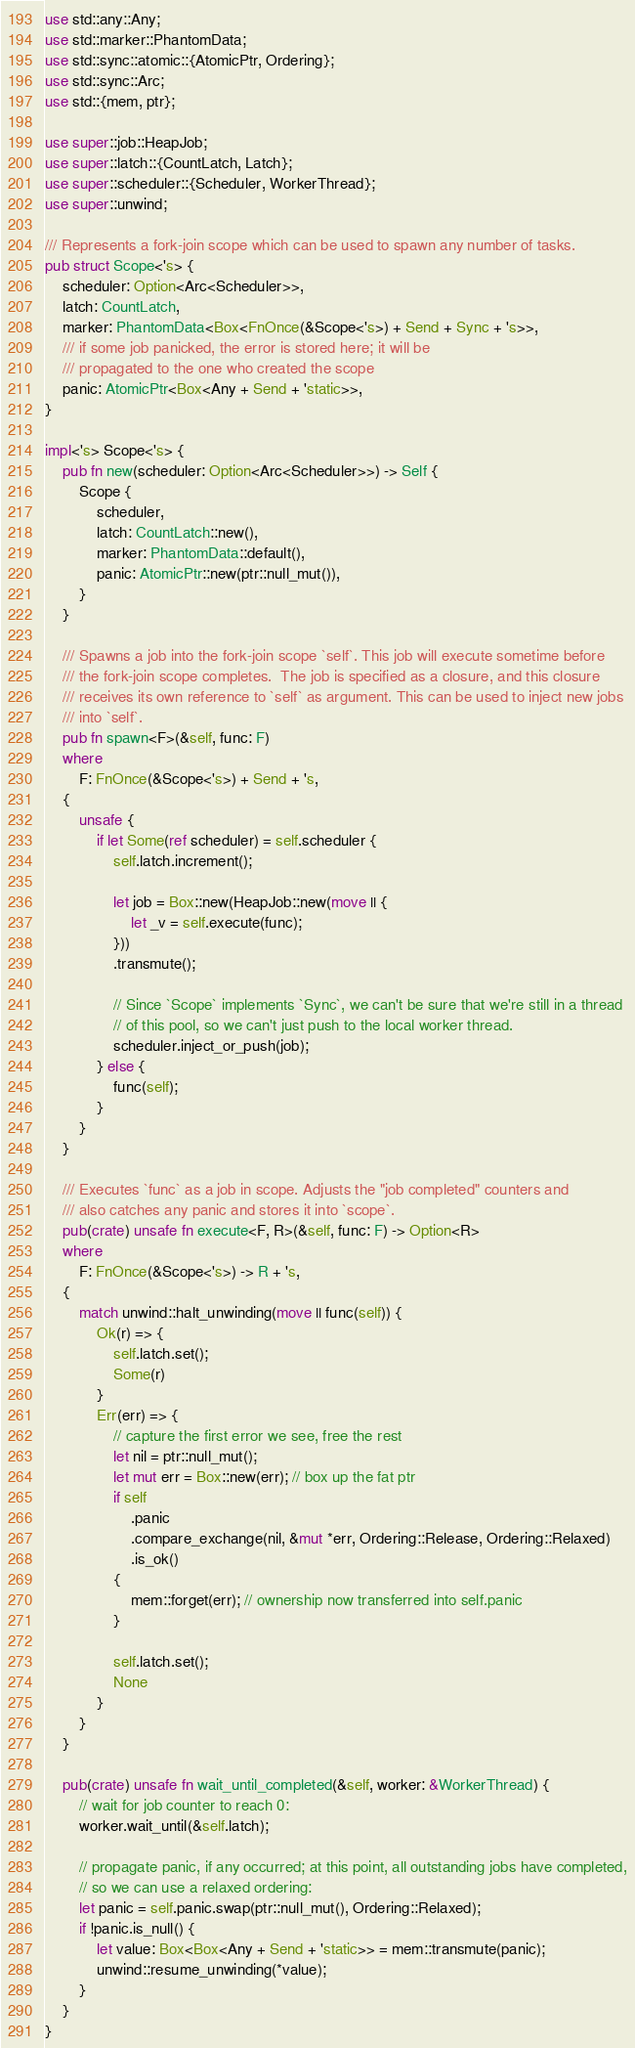Convert code to text. <code><loc_0><loc_0><loc_500><loc_500><_Rust_>use std::any::Any;
use std::marker::PhantomData;
use std::sync::atomic::{AtomicPtr, Ordering};
use std::sync::Arc;
use std::{mem, ptr};

use super::job::HeapJob;
use super::latch::{CountLatch, Latch};
use super::scheduler::{Scheduler, WorkerThread};
use super::unwind;

/// Represents a fork-join scope which can be used to spawn any number of tasks.
pub struct Scope<'s> {
    scheduler: Option<Arc<Scheduler>>,
    latch: CountLatch,
    marker: PhantomData<Box<FnOnce(&Scope<'s>) + Send + Sync + 's>>,
    /// if some job panicked, the error is stored here; it will be
    /// propagated to the one who created the scope
    panic: AtomicPtr<Box<Any + Send + 'static>>,
}

impl<'s> Scope<'s> {
    pub fn new(scheduler: Option<Arc<Scheduler>>) -> Self {
        Scope {
            scheduler,
            latch: CountLatch::new(),
            marker: PhantomData::default(),
            panic: AtomicPtr::new(ptr::null_mut()),
        }
    }

    /// Spawns a job into the fork-join scope `self`. This job will execute sometime before
    /// the fork-join scope completes.  The job is specified as a closure, and this closure
    /// receives its own reference to `self` as argument. This can be used to inject new jobs
    /// into `self`.
    pub fn spawn<F>(&self, func: F)
    where
        F: FnOnce(&Scope<'s>) + Send + 's,
    {
        unsafe {
            if let Some(ref scheduler) = self.scheduler {
                self.latch.increment();

                let job = Box::new(HeapJob::new(move || {
                    let _v = self.execute(func);
                }))
                .transmute();

                // Since `Scope` implements `Sync`, we can't be sure that we're still in a thread
                // of this pool, so we can't just push to the local worker thread.
                scheduler.inject_or_push(job);
            } else {
                func(self);
            }
        }
    }

    /// Executes `func` as a job in scope. Adjusts the "job completed" counters and
    /// also catches any panic and stores it into `scope`.
    pub(crate) unsafe fn execute<F, R>(&self, func: F) -> Option<R>
    where
        F: FnOnce(&Scope<'s>) -> R + 's,
    {
        match unwind::halt_unwinding(move || func(self)) {
            Ok(r) => {
                self.latch.set();
                Some(r)
            }
            Err(err) => {
                // capture the first error we see, free the rest
                let nil = ptr::null_mut();
                let mut err = Box::new(err); // box up the fat ptr
                if self
                    .panic
                    .compare_exchange(nil, &mut *err, Ordering::Release, Ordering::Relaxed)
                    .is_ok()
                {
                    mem::forget(err); // ownership now transferred into self.panic
                }

                self.latch.set();
                None
            }
        }
    }

    pub(crate) unsafe fn wait_until_completed(&self, worker: &WorkerThread) {
        // wait for job counter to reach 0:
        worker.wait_until(&self.latch);

        // propagate panic, if any occurred; at this point, all outstanding jobs have completed,
        // so we can use a relaxed ordering:
        let panic = self.panic.swap(ptr::null_mut(), Ordering::Relaxed);
        if !panic.is_null() {
            let value: Box<Box<Any + Send + 'static>> = mem::transmute(panic);
            unwind::resume_unwinding(*value);
        }
    }
}
</code> 